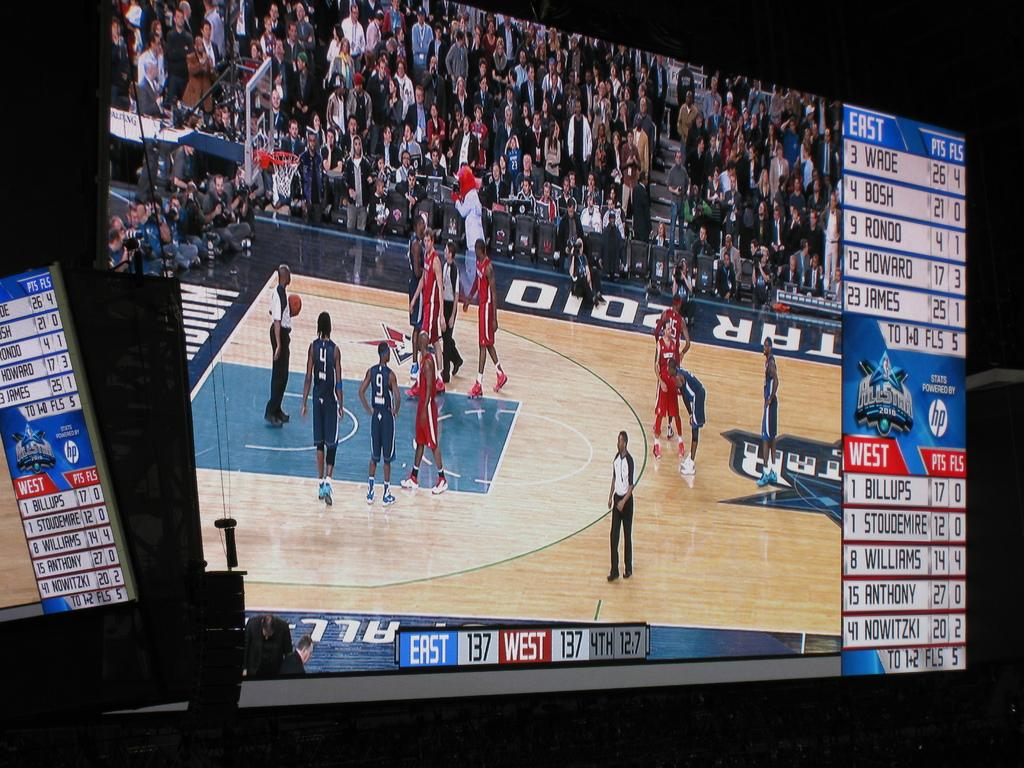<image>
Summarize the visual content of the image. The East and the West teams are tied in the 4th quarter. 